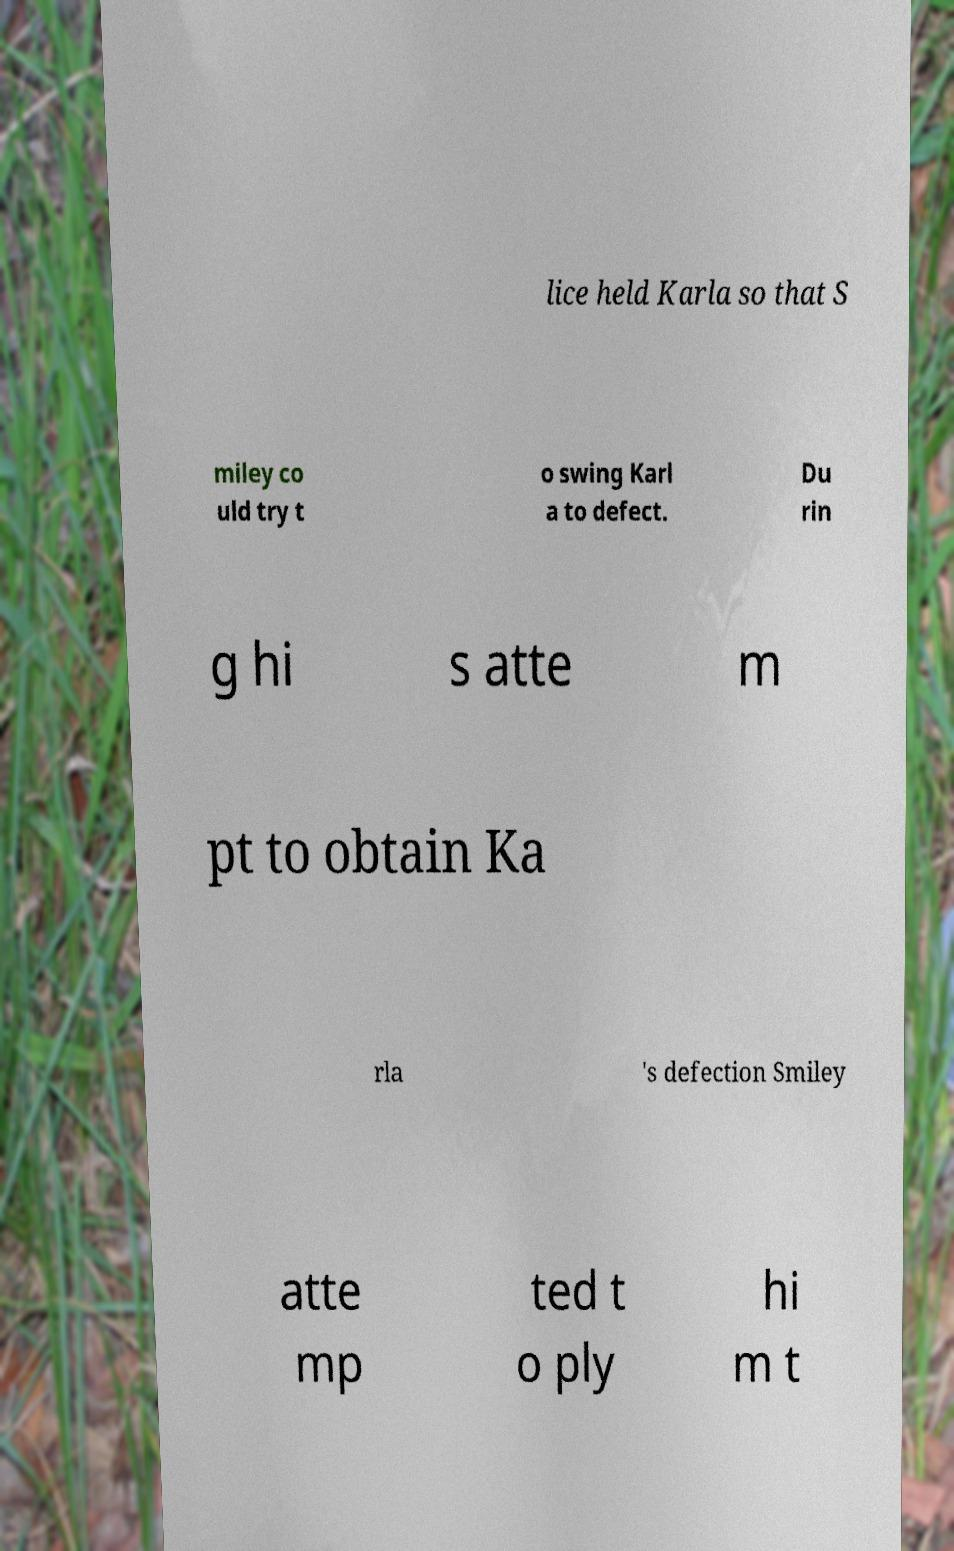For documentation purposes, I need the text within this image transcribed. Could you provide that? lice held Karla so that S miley co uld try t o swing Karl a to defect. Du rin g hi s atte m pt to obtain Ka rla 's defection Smiley atte mp ted t o ply hi m t 